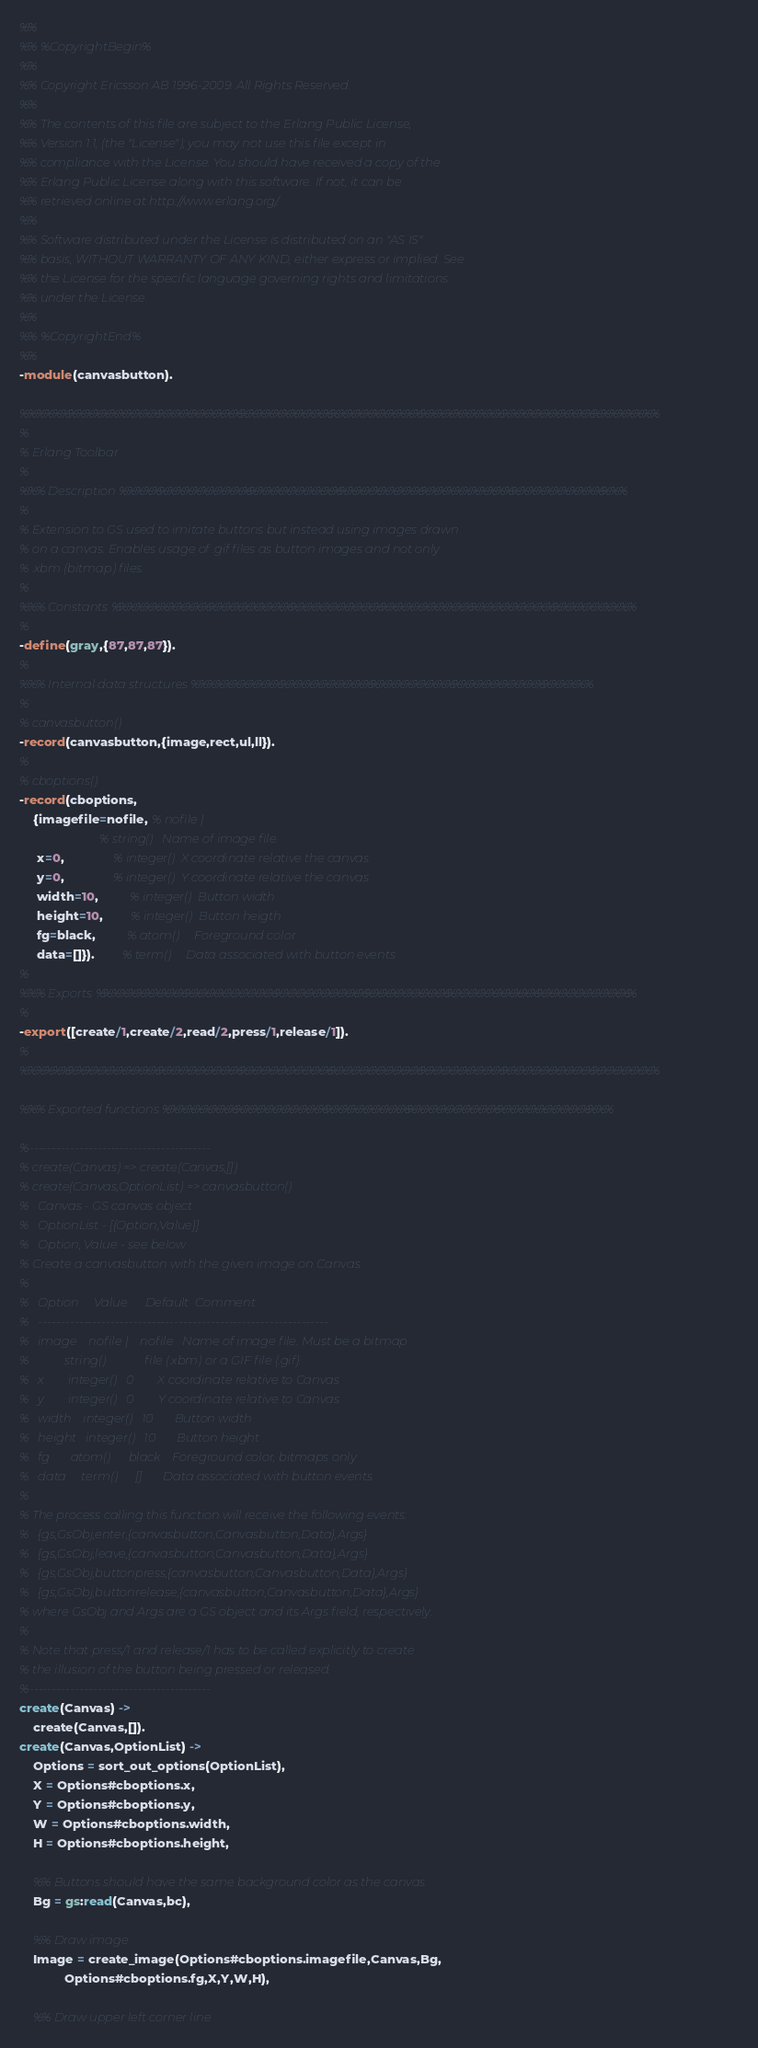Convert code to text. <code><loc_0><loc_0><loc_500><loc_500><_Erlang_>%%
%% %CopyrightBegin%
%% 
%% Copyright Ericsson AB 1996-2009. All Rights Reserved.
%% 
%% The contents of this file are subject to the Erlang Public License,
%% Version 1.1, (the "License"); you may not use this file except in
%% compliance with the License. You should have received a copy of the
%% Erlang Public License along with this software. If not, it can be
%% retrieved online at http://www.erlang.org/.
%% 
%% Software distributed under the License is distributed on an "AS IS"
%% basis, WITHOUT WARRANTY OF ANY KIND, either express or implied. See
%% the License for the specific language governing rights and limitations
%% under the License.
%% 
%% %CopyrightEnd%
%%
-module(canvasbutton).

%%%%%%%%%%%%%%%%%%%%%%%%%%%%%%%%%%%%%%%%%%%%%%%%%%%%%%%%%%%%%%%%%%%%%%%%%%%%%%
%
% Erlang Toolbar
%
%%% Description %%%%%%%%%%%%%%%%%%%%%%%%%%%%%%%%%%%%%%%%%%%%%%%%%%%%%%%%%%%%%%
%
% Extension to GS used to imitate buttons but instead using images drawn
% on a canvas. Enables usage of .gif files as button images and not only
% .xbm (bitmap) files.
%
%%% Constants %%%%%%%%%%%%%%%%%%%%%%%%%%%%%%%%%%%%%%%%%%%%%%%%%%%%%%%%%%%%%%%%
%
-define(gray,{87,87,87}).
%
%%% Internal data structures %%%%%%%%%%%%%%%%%%%%%%%%%%%%%%%%%%%%%%%%%%%%%%%%%
%
% canvasbutton()
-record(canvasbutton,{image,rect,ul,ll}).
%
% cboptions()
-record(cboptions,
	{imagefile=nofile, % nofile |
	                   % string()   Name of image file
	 x=0,              % integer()  X coordinate relative the canvas
	 y=0,              % integer()  Y coordinate relative the canvas
	 width=10,         % integer()  Button width
	 height=10,        % integer()  Button heigth
	 fg=black,         % atom()     Foreground color
	 data=[]}).        % term()     Data associated with button events
%
%%% Exports %%%%%%%%%%%%%%%%%%%%%%%%%%%%%%%%%%%%%%%%%%%%%%%%%%%%%%%%%%%%%%%%%%
%
-export([create/1,create/2,read/2,press/1,release/1]).
%
%%%%%%%%%%%%%%%%%%%%%%%%%%%%%%%%%%%%%%%%%%%%%%%%%%%%%%%%%%%%%%%%%%%%%%%%%%%%%%

%%% Exported functions %%%%%%%%%%%%%%%%%%%%%%%%%%%%%%%%%%%%%%%%%%%%%%%%%%%%%%%

%----------------------------------------
% create(Canvas) => create(Canvas,[])
% create(Canvas,OptionList) => canvasbutton()
%   Canvas - GS canvas object
%   OptionList - [{Option,Value}]
%   Option, Value - see below
% Create a canvasbutton with the given image on Canvas
%
%   Option     Value      Default  Comment
%   ----------------------------------------------------------------
%   image    nofile |    nofile   Name of image file. Must be a bitmap
%            string()             file (.xbm) or a GIF file (.gif).
%   x        integer()   0        X coordinate relative to Canvas
%   y        integer()   0        Y coordinate relative to Canvas
%   width    integer()   10       Button width
%   height   integer()   10       Button height
%   fg       atom()      black    Foreground color, bitmaps only
%   data     term()      []       Data associated with button events
%
% The process calling this function will receive the following events:
%   {gs,GsObj,enter,{canvasbutton,Canvasbutton,Data},Args}
%   {gs,GsObj,leave,{canvasbutton,Canvasbutton,Data},Args}
%   {gs,GsObj,buttonpress,{canvasbutton,Canvasbutton,Data},Args}
%   {gs,GsObj,buttonrelease,{canvasbutton,Canvasbutton,Data},Args}
% where GsObj and Args are a GS object and its Args field, respectively.
%
% Note that press/1 and release/1 has to be called explicitly to create
% the illusion of the button being pressed or released.
%----------------------------------------
create(Canvas) ->
    create(Canvas,[]).
create(Canvas,OptionList) ->
    Options = sort_out_options(OptionList),
    X = Options#cboptions.x,
    Y = Options#cboptions.y,
    W = Options#cboptions.width,
    H = Options#cboptions.height,

    %% Buttons should have the same background color as the canvas
    Bg = gs:read(Canvas,bc),

    %% Draw image
    Image = create_image(Options#cboptions.imagefile,Canvas,Bg,
			 Options#cboptions.fg,X,Y,W,H),

    %% Draw upper left corner line</code> 